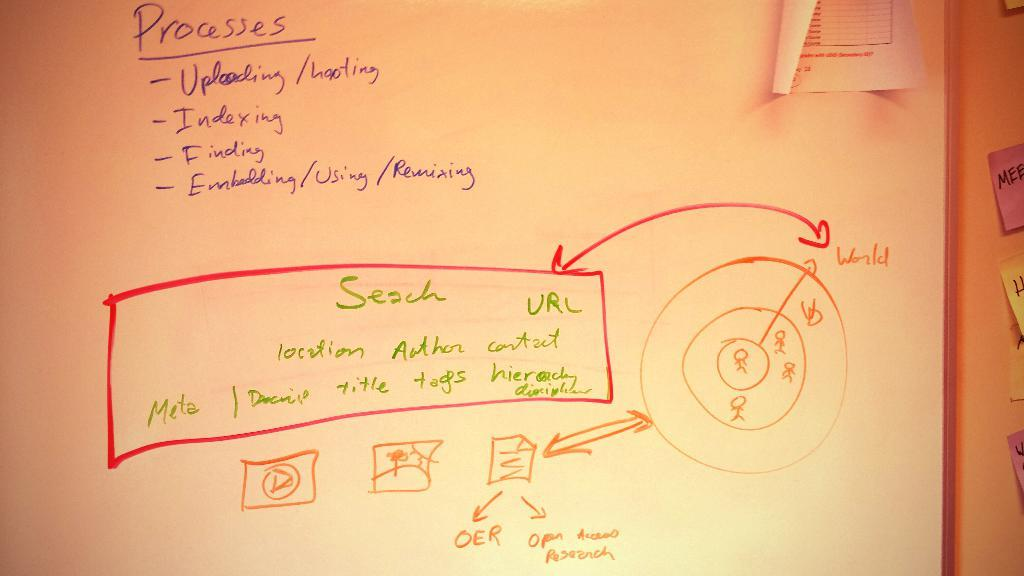<image>
Render a clear and concise summary of the photo. The processes for uploading and indexing URLs is shown on the white board. 